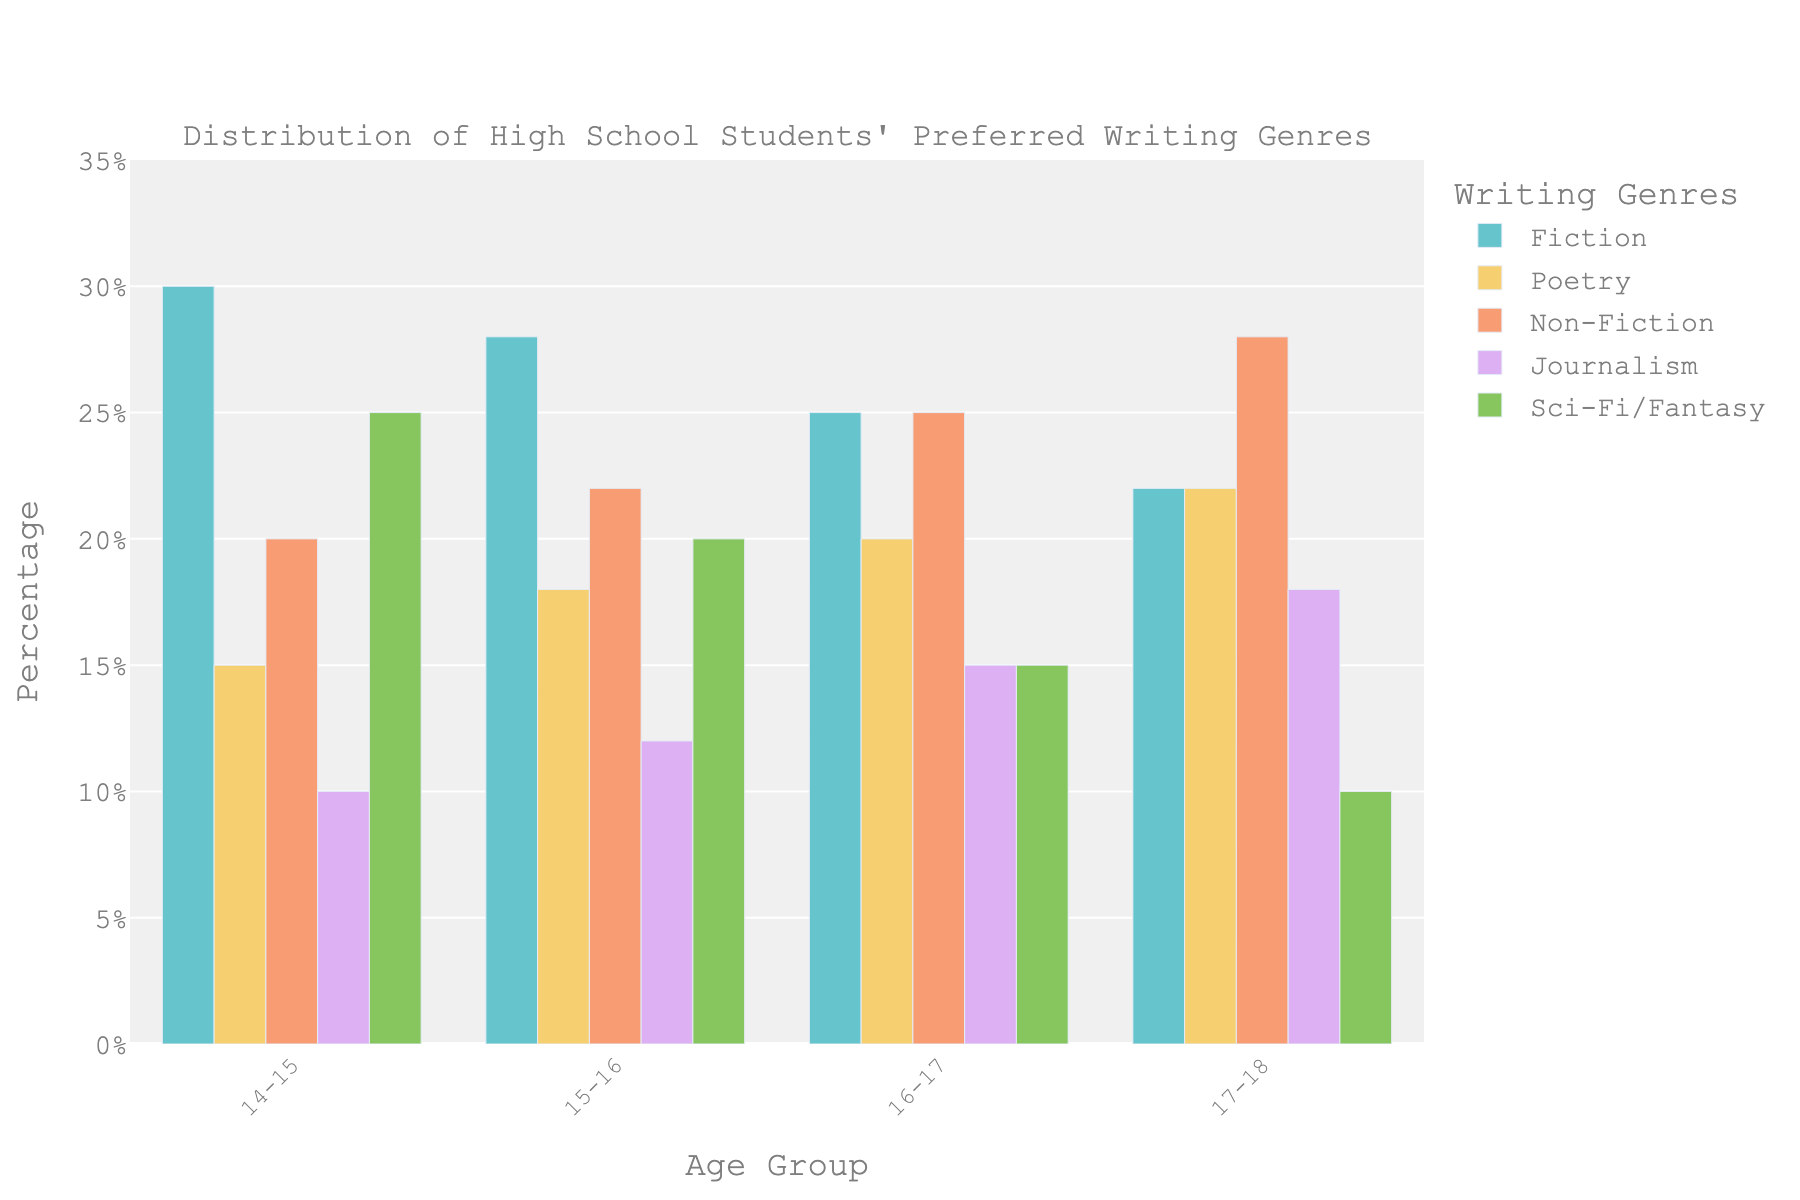What's the most preferred writing genre for students aged 14-15? The highest bar in the 14-15 age group corresponds to Fiction with a height of 30%, indicating it's the most preferred writing genre in this age group.
Answer: Fiction Which age group shows the highest preference for Non-Fiction? By comparing the heights of the Non-Fiction bars, the tallest bar is in the 17-18 age group with a height of 28%, showing the highest preference for Non-Fiction.
Answer: 17-18 Among the 15-16 age group, which two genres are preferred equally? Observing the bar heights for the 15-16 age group, Sci-Fi/Fantasy and Non-Fiction both stand at 20%. Thus, these two genres are equally preferred.
Answer: Sci-Fi/Fantasy and Non-Fiction What is the combined preference percentage for Poetry and Journalism for the 16-17 age group? The preference for Poetry is 20% and Journalism is 15% in the 16-17 age group. Adding them together, 20% + 15% = 35%.
Answer: 35% Between the 14-15 and 17-18 age groups, how does preference for Sci-Fi/Fantasy change? The bar height for Sci-Fi/Fantasy in the 14-15 age group is 25%, and in the 17-18 age group, it's 10%. The preference decreases by 15 percentage points.
Answer: Decreases by 15% In which age group is Journalism least preferred? The shortest bar representing Journalism is in the 14-15 age group with a height of 10%, indicating it's least preferred there.
Answer: 14-15 Which writing genre shows a steady increase in preference as the age groups progress? Observing the bars, Non-Fiction shows a steady increase from 20% to 22% to 25% to 28% as age groups progress from 14-15 to 17-18.
Answer: Non-Fiction What’s the difference in preference for Fiction between the youngest and the oldest age group? The bar height for Fiction is 30% for the 14-15 age group and 22% for the 17-18 age group. The difference is 30% - 22% = 8%.
Answer: 8% Which genre has the most balanced preference across all age groups? Checking the bar heights, Poetry ranges from 15% to 22% across all groups, showing it has the smallest variation and is most balanced.
Answer: Poetry How does preference for Fiction change as students get older? The preference for Fiction decreases overall as the age groups progress, starting from 30% in the 14-15 age group and decreasing to 22% in the 17-18 age group.
Answer: Decreases 